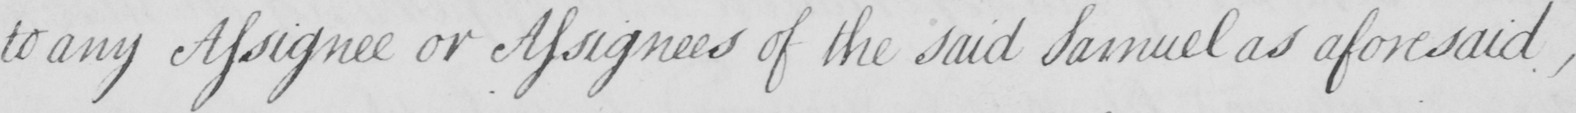Please transcribe the handwritten text in this image. to any Assignee or Assignees of the said Samuel as aforesaid , 